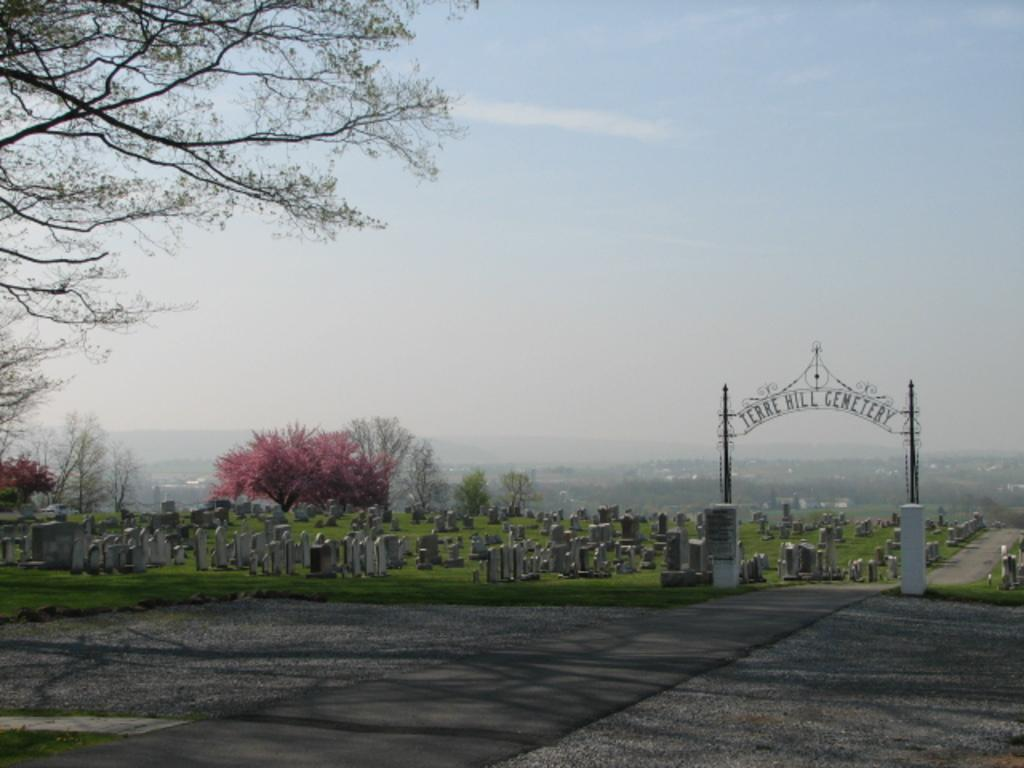What type of structure can be seen in the image? There is an arch in the image. What is located near the arch? There is a graveyard in the image. What is in front of the arch and graveyard? There is a road in front of the image. What can be seen in the background of the image? There are trees and the sky visible in the background of the image. What type of channel can be seen in the image? There is no channel present in the image. What type of cabbage is growing in the graveyard? There is no cabbage present in the image, and the graveyard is not a place for growing plants. 